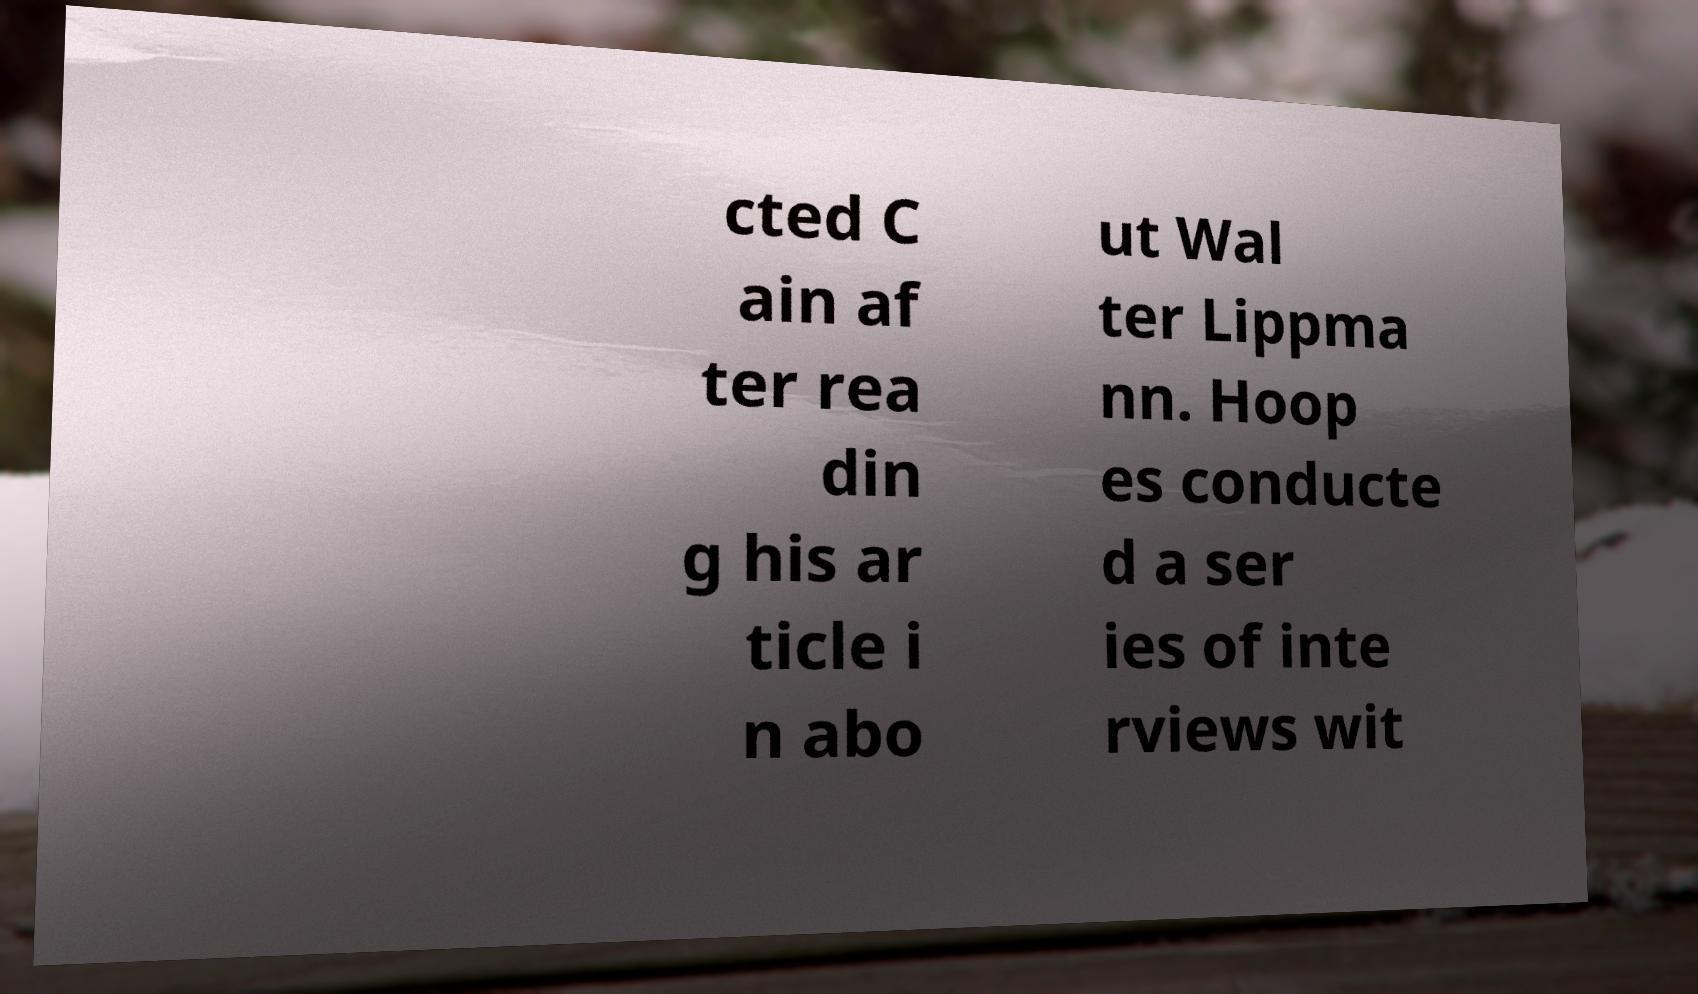Could you extract and type out the text from this image? cted C ain af ter rea din g his ar ticle i n abo ut Wal ter Lippma nn. Hoop es conducte d a ser ies of inte rviews wit 